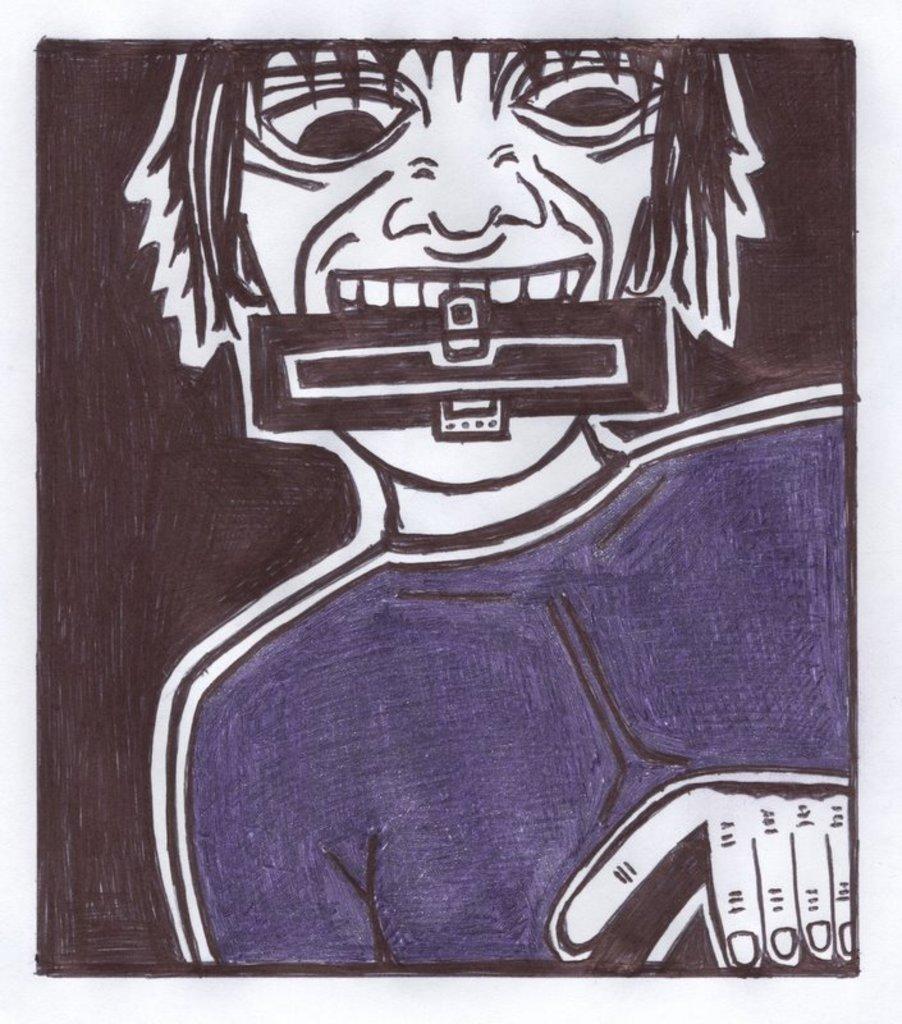Describe this image in one or two sentences. Here we can see a drawing of a person holding an object with his mouth. 